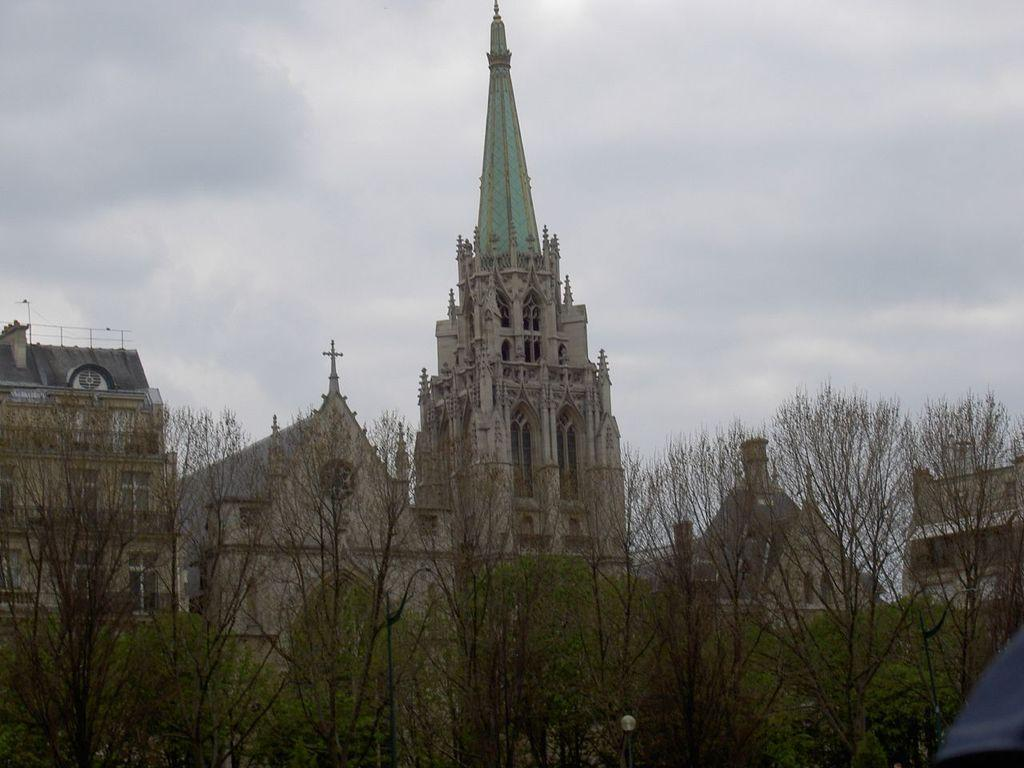What type of structure can be seen in the image? There is a light pole in the image. What other objects are present in the image? There are trees and buildings in the image. What is the condition of the sky in the image? The sky is cloudy in the image. What type of trousers are hanging on the light pole in the image? There are no trousers present on the light pole or in the image. What type of property is being sold in the image? There is no property being sold in the image; it only features a light pole, trees, buildings, and a cloudy sky. 